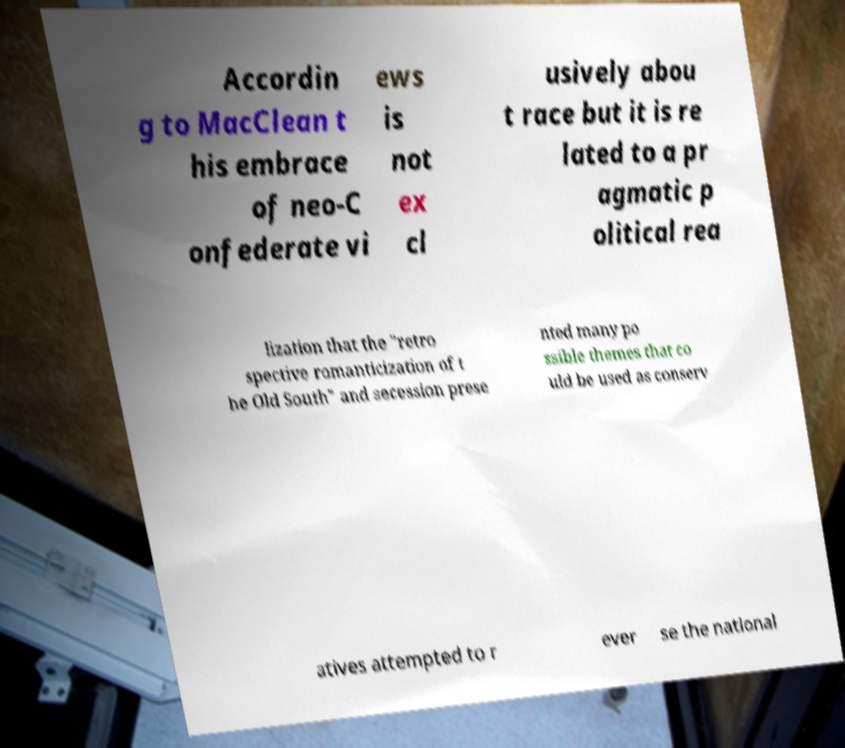Can you read and provide the text displayed in the image?This photo seems to have some interesting text. Can you extract and type it out for me? Accordin g to MacClean t his embrace of neo-C onfederate vi ews is not ex cl usively abou t race but it is re lated to a pr agmatic p olitical rea lization that the "retro spective romanticization of t he Old South" and secession prese nted many po ssible themes that co uld be used as conserv atives attempted to r ever se the national 